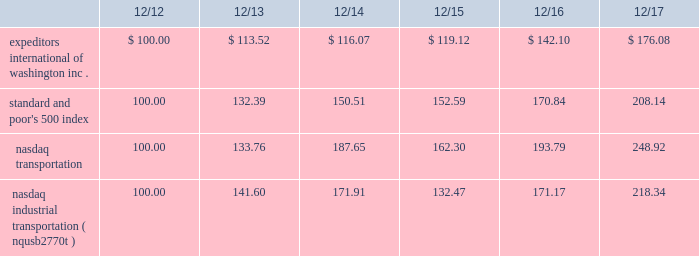The graph below compares expeditors international of washington , inc.'s cumulative 5-year total shareholder return on common stock with the cumulative total returns of the s&p 500 index , the nasdaq transportation index , and the nasdaq industrial transportation index ( nqusb2770t ) as a replacement for the nasdaq transportation index .
The company is making the modification to reference a specific transportation index and to source that data directly from nasdaq .
The graph assumes that the value of the investment in our common stock and in each of the indexes ( including reinvestment of dividends ) was $ 100 on 12/31/2012 and tracks it through 12/31/2017 .
Total return assumes reinvestment of dividends in each of the indices indicated .
Comparison of 5-year cumulative total return among expeditors international of washington , inc. , the s&p 500 index , the nasdaq industrial transportation index and the nasdaq transportation index. .
The stock price performance included in this graph is not necessarily indicative of future stock price performance .
Item 6 2014 selected financial data financial highlights in thousands , except per share data 2017 2016 2015 2014 2013 revenues ..................................................................... .
$ 6920948 6098037 6616632 6564721 6080257 net revenues1 ............................................................... .
$ 2319189 2164036 2187777 1981427 1882853 net earnings attributable to shareholders ..................... .
$ 489345 430807 457223 376888 348526 diluted earnings attributable to shareholders per share $ 2.69 2.36 2.40 1.92 1.68 basic earnings attributable to shareholders per share.. .
$ 2.73 2.38 2.42 1.92 1.69 dividends declared and paid per common share.......... .
$ 0.84 0.80 0.72 0.64 0.60 cash used for dividends ............................................... .
$ 150495 145123 135673 124634 123292 cash used for share repurchases ................................. .
$ 478258 337658 629991 550781 261936 working capital ............................................................. .
$ 1448333 1288648 1115136 1285188 1526673 total assets .................................................................. .
$ 3117008 2790871 2565577 2870626 2996416 shareholders 2019 equity ..................................................... .
$ 1991858 1844638 1691993 1868408 2084783 weighted average diluted shares outstanding .............. .
181666 182704 190223 196768 206895 weighted average basic shares outstanding ................ .
179247 181282 188941 196147 205995 _______________________ 1non-gaap measure calculated as revenues less directly related operating expenses attributable to our principal services .
See management's discussion and analysis for a reconciliation of net revenues to revenues .
Safe harbor for forward-looking statements under private securities litigation reform act of 1995 ; certain cautionary statements this annual report on form 10-k for the fiscal year ended december 31 , 2017 contains 201cforward-looking statements , 201d as defined in section 27a of the securities act of 1933 , as amended , and section 21e of the securities exchange act of 1934 , as amended .
From time to time , expeditors or its representatives have made or may make forward-looking statements , orally or in writing .
Such forward-looking statements may be included in , but not limited to , press releases , presentations , oral statements made with the approval of an authorized executive officer or in various filings made by expeditors with the securities and exchange commission .
Statements including those preceded by , followed by or that include the words or phrases 201cwill likely result 201d , 201care expected to 201d , "would expect" , "would not expect" , 201cwill continue 201d , 201cis anticipated 201d , 201cestimate 201d , 201cproject 201d , "provisional" , "plan" , "believe" , "probable" , "reasonably possible" , "may" , "could" , "should" , "intends" , "foreseeable future" or similar expressions are intended to identify 201cforward-looking statements 201d within the meaning of the private securities litigation reform act of 1995 .
Such statements are qualified in their entirety by reference to and are accompanied by the discussion in item 1a of certain important factors that could cause actual results to differ materially from such forward-looking statements .
The risks included in item 1a are not exhaustive .
Furthermore , reference is also made to other sections of this report , which include additional factors that could adversely impact expeditors' business and financial performance .
Moreover , expeditors operates in a very competitive , complex and rapidly changing global environment .
New risk factors emerge from time to time and it is not possible for management to predict all of such risk factors , nor can it assess the impact of all of such risk factors on expeditors' business or the extent to which any factor , or combination of factors , may cause actual results to differ materially from those contained in any forward-looking statements .
Accordingly , forward-looking statements cannot be relied upon as a guarantee of actual results .
Shareholders should be aware that while expeditors does , from time to time , communicate with securities analysts , it is against expeditors' policy to disclose to such analysts any material non-public information or other confidential commercial information .
Accordingly , shareholders should not assume that expeditors agrees with any statement or report issued by any analyst irrespective of the content of such statement or report .
Furthermore , expeditors has a policy against issuing financial forecasts or projections or confirming the accuracy of forecasts or projections issued by others .
Accordingly , to the extent that reports issued by securities analysts contain any projections , forecasts or opinions , such reports are not the responsibility of expeditors. .
What is the difference in percentage return between expeditors international of washington inc . and the standard and poor's 500 index for the five years ended 12/17? 
Computations: (((176.08 - 100) / 100) - ((208.14 - 100) / 100))
Answer: -0.3206. 